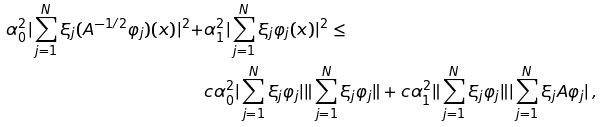Convert formula to latex. <formula><loc_0><loc_0><loc_500><loc_500>\alpha _ { 0 } ^ { 2 } | \sum ^ { N } _ { j = 1 } \xi _ { j } ( A ^ { - 1 / 2 } \varphi _ { j } ) ( x ) | ^ { 2 } + & \alpha _ { 1 } ^ { 2 } | \sum ^ { N } _ { j = 1 } \xi _ { j } \varphi _ { j } ( x ) | ^ { 2 } \leq \\ & c \alpha _ { 0 } ^ { 2 } | \sum ^ { N } _ { j = 1 } \xi _ { j } \varphi _ { j } | \| \sum ^ { N } _ { j = 1 } \xi _ { j } \varphi _ { j } \| + c \alpha _ { 1 } ^ { 2 } \| \sum ^ { N } _ { j = 1 } \xi _ { j } \varphi _ { j } \| | \sum ^ { N } _ { j = 1 } \xi _ { j } A \varphi _ { j } | \, ,</formula> 